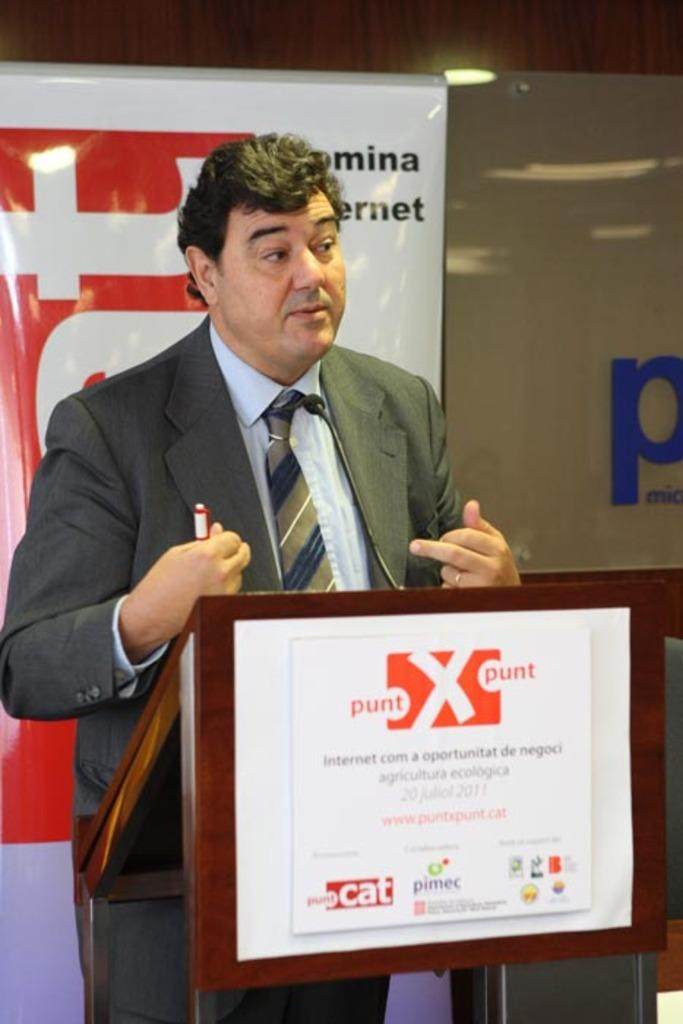Who is the main subject in the image? There is a man in the middle of the image. What is the man standing in front of? There is a podium in front of the man. What can be seen in the background of the image? There is a banner in the background of the image. What object is the man holding? The man is holding a marker. What type of wound can be seen on the man's arm in the image? There is no wound visible on the man's arm in the image. What kind of toys are scattered around the man in the image? There are no toys present in the image. 